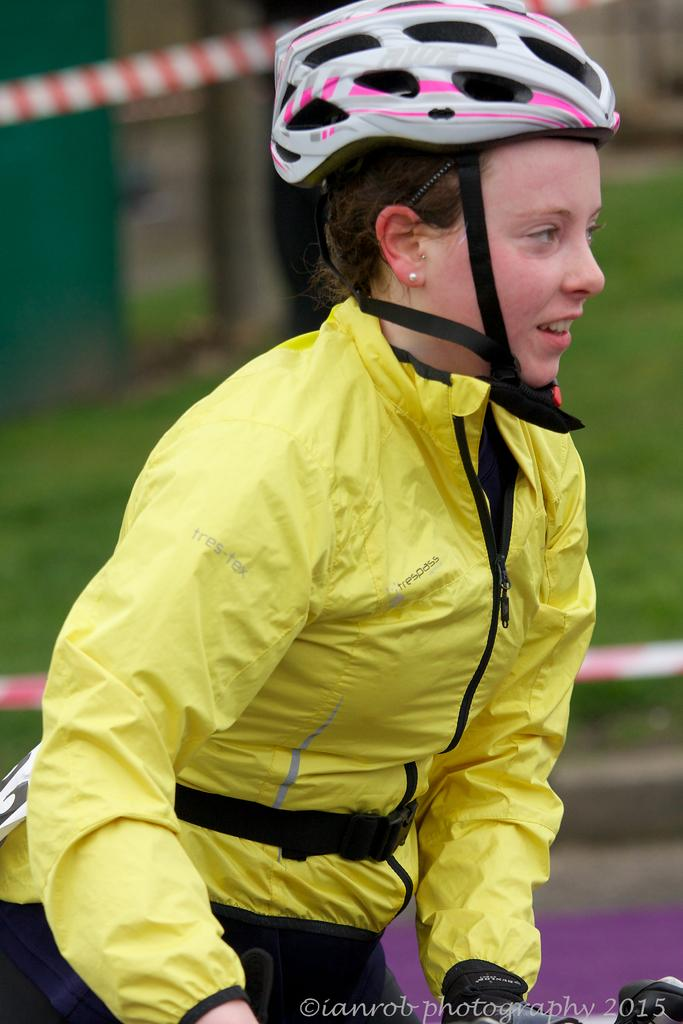Who is present in the image? There is a woman in the image. What is the woman wearing on her upper body? The woman is wearing a yellow jacket. What type of headgear is the woman wearing? The woman is wearing a helmet. Can you describe the background of the image? The background of the image is blurred, but grass and ropes are visible. What type of fruit is the woman holding in the image? There is no fruit visible in the image; the woman is wearing a helmet and a yellow jacket. What kind of fish can be seen swimming in the background of the image? There are no fish present in the image; the background features grass and ropes. 